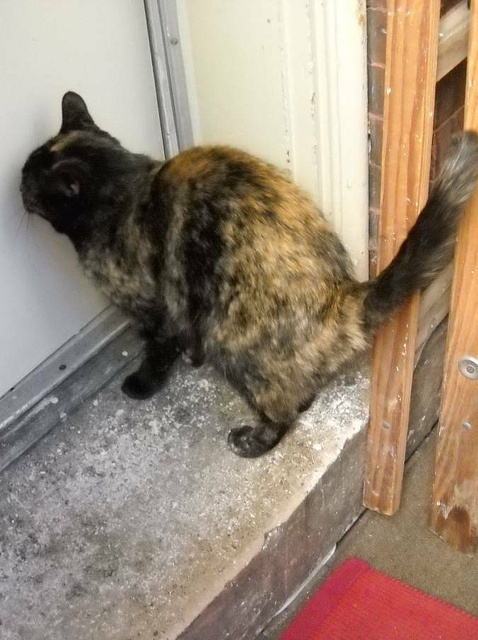Describe the objects in this image and their specific colors. I can see a cat in lightgray, black, gray, and tan tones in this image. 